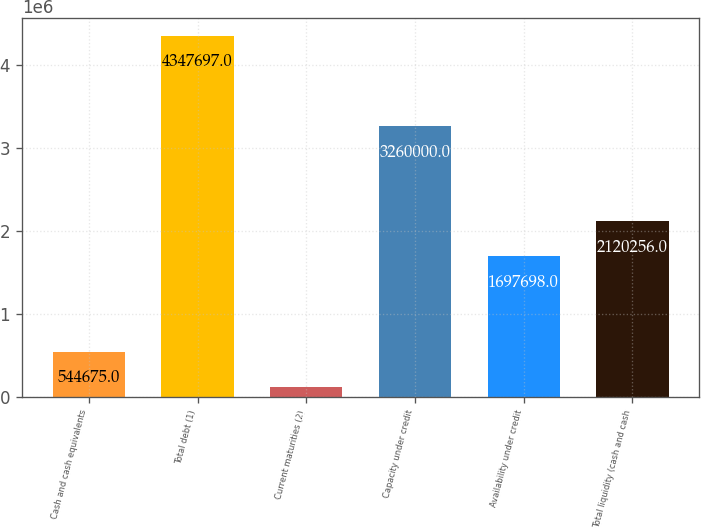Convert chart. <chart><loc_0><loc_0><loc_500><loc_500><bar_chart><fcel>Cash and cash equivalents<fcel>Total debt (1)<fcel>Current maturities (2)<fcel>Capacity under credit<fcel>Availability under credit<fcel>Total liquidity (cash and cash<nl><fcel>544675<fcel>4.3477e+06<fcel>122117<fcel>3.26e+06<fcel>1.6977e+06<fcel>2.12026e+06<nl></chart> 